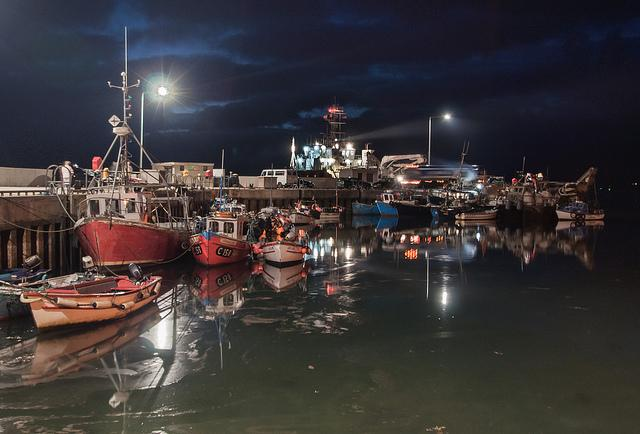What do the small floats on the boats sides here meant to prevent the boats doing? Please explain your reasoning. bumping. They will allow the boats to rock in the water without hitting each other and scratching each other. 